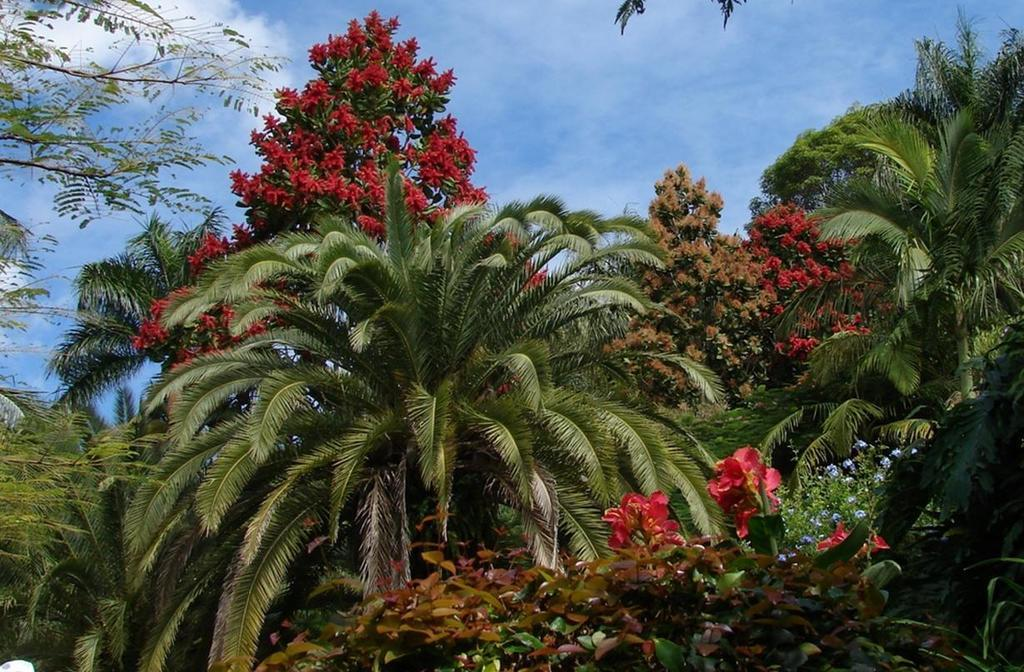What types of vegetation can be seen in the image? There are different types of trees in the image. Are there any additional features on the trees? Yes, there are flowers on the trees. What is visible at the top of the image? The sky is visible at the top of the image. What can be observed in the sky? There are clouds in the sky. How many rings are visible on the tree trunks in the image? There is no mention of tree rings in the provided facts, so it cannot be determined from the image. 